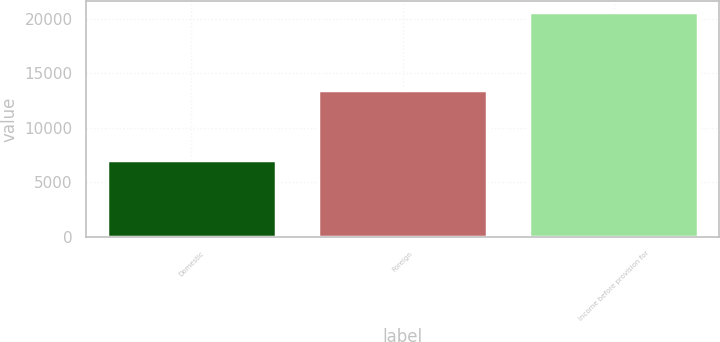Convert chart. <chart><loc_0><loc_0><loc_500><loc_500><bar_chart><fcel>Domestic<fcel>Foreign<fcel>Income before provision for<nl><fcel>7079<fcel>13515<fcel>20594<nl></chart> 